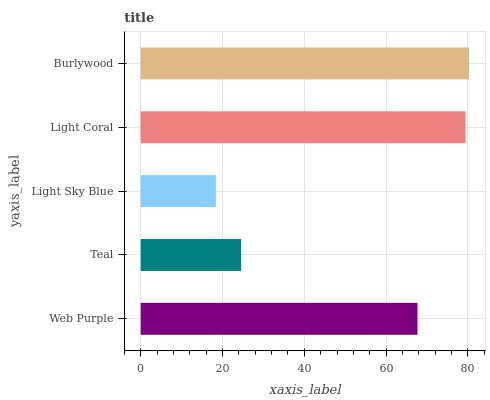Is Light Sky Blue the minimum?
Answer yes or no. Yes. Is Burlywood the maximum?
Answer yes or no. Yes. Is Teal the minimum?
Answer yes or no. No. Is Teal the maximum?
Answer yes or no. No. Is Web Purple greater than Teal?
Answer yes or no. Yes. Is Teal less than Web Purple?
Answer yes or no. Yes. Is Teal greater than Web Purple?
Answer yes or no. No. Is Web Purple less than Teal?
Answer yes or no. No. Is Web Purple the high median?
Answer yes or no. Yes. Is Web Purple the low median?
Answer yes or no. Yes. Is Light Sky Blue the high median?
Answer yes or no. No. Is Burlywood the low median?
Answer yes or no. No. 